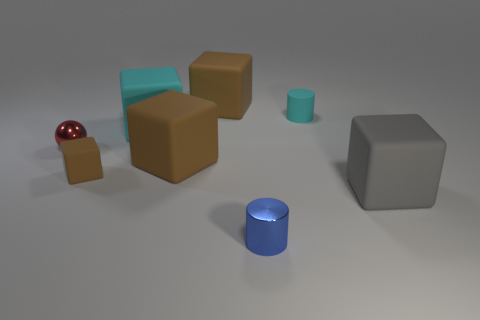Subtract all cyan spheres. How many brown blocks are left? 3 Subtract all gray blocks. How many blocks are left? 4 Subtract all small brown matte cubes. How many cubes are left? 4 Add 1 tiny cyan rubber objects. How many objects exist? 9 Subtract all purple cubes. Subtract all brown balls. How many cubes are left? 5 Subtract all balls. How many objects are left? 7 Subtract 0 gray balls. How many objects are left? 8 Subtract all tiny brown things. Subtract all yellow metal cubes. How many objects are left? 7 Add 4 cyan rubber objects. How many cyan rubber objects are left? 6 Add 5 tiny red metallic things. How many tiny red metallic things exist? 6 